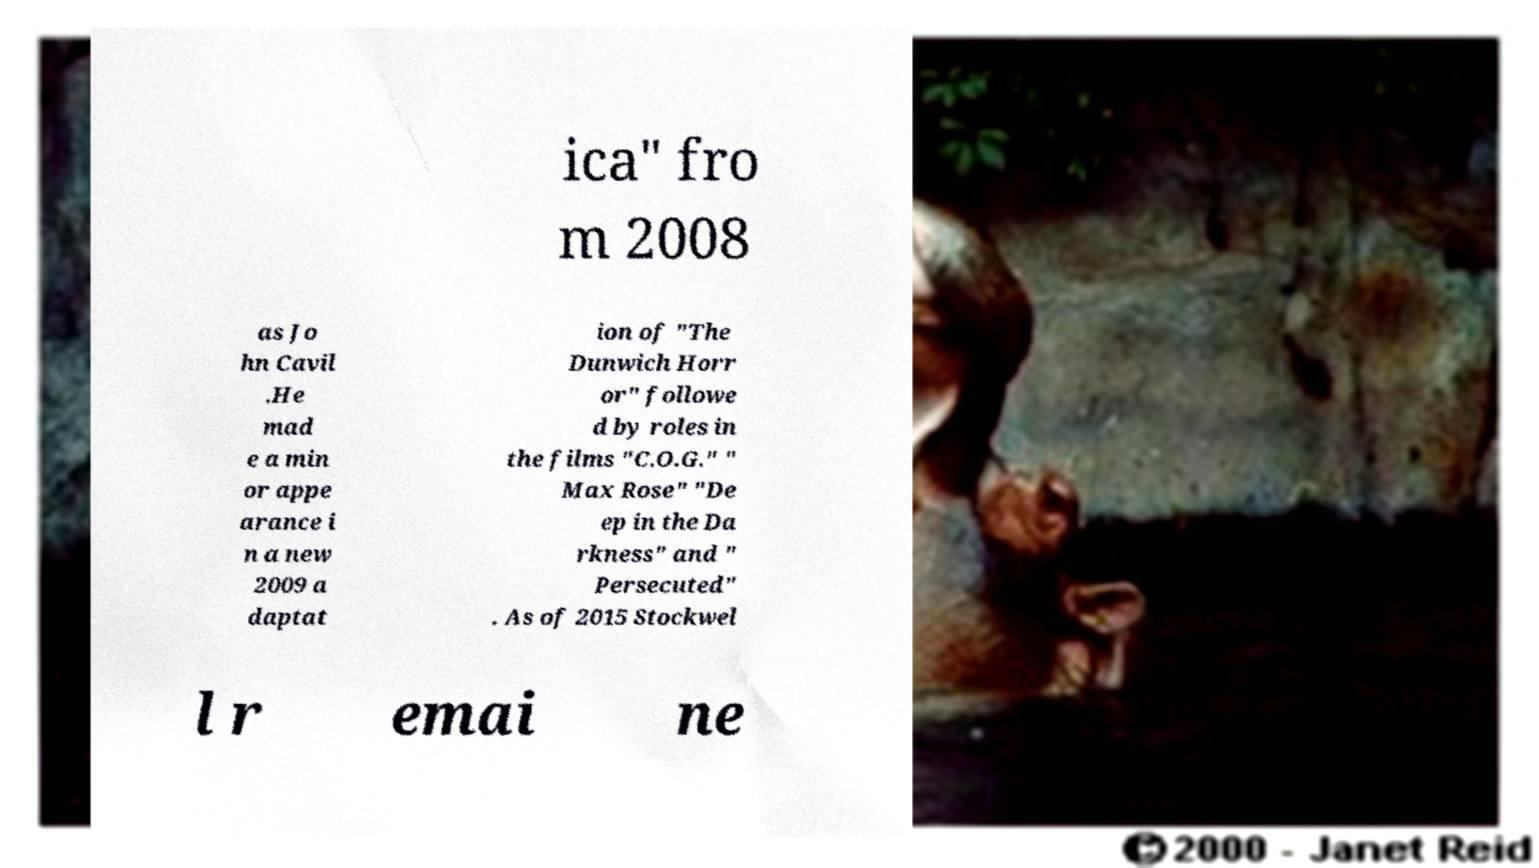Please identify and transcribe the text found in this image. ica" fro m 2008 as Jo hn Cavil .He mad e a min or appe arance i n a new 2009 a daptat ion of "The Dunwich Horr or" followe d by roles in the films "C.O.G." " Max Rose" "De ep in the Da rkness" and " Persecuted" . As of 2015 Stockwel l r emai ne 